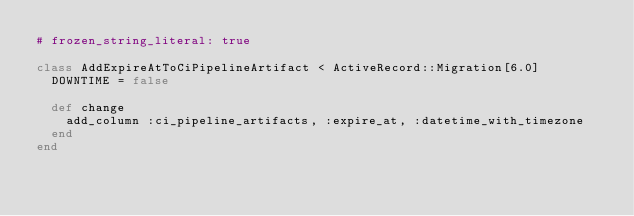Convert code to text. <code><loc_0><loc_0><loc_500><loc_500><_Ruby_># frozen_string_literal: true

class AddExpireAtToCiPipelineArtifact < ActiveRecord::Migration[6.0]
  DOWNTIME = false

  def change
    add_column :ci_pipeline_artifacts, :expire_at, :datetime_with_timezone
  end
end
</code> 